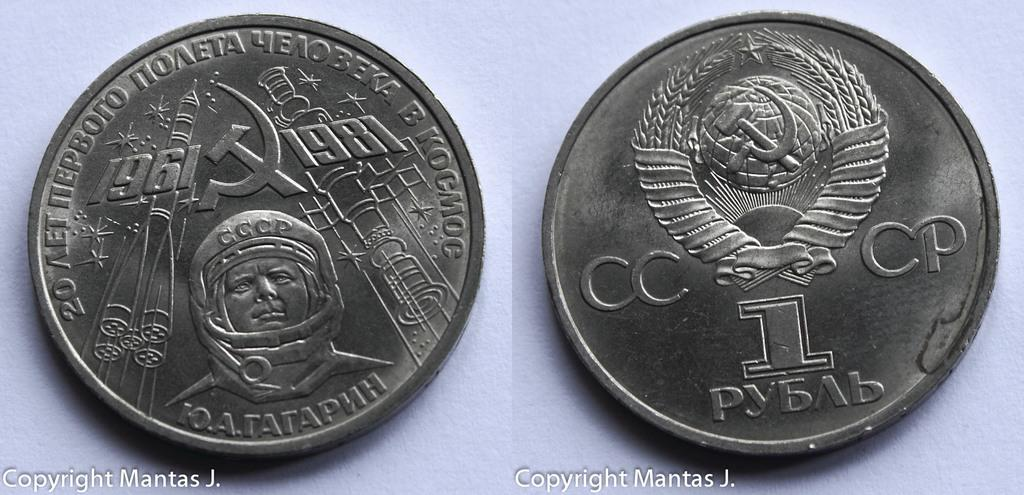Provide a one-sentence caption for the provided image. The front and backside of a silver coin from a foreign country are showing. 